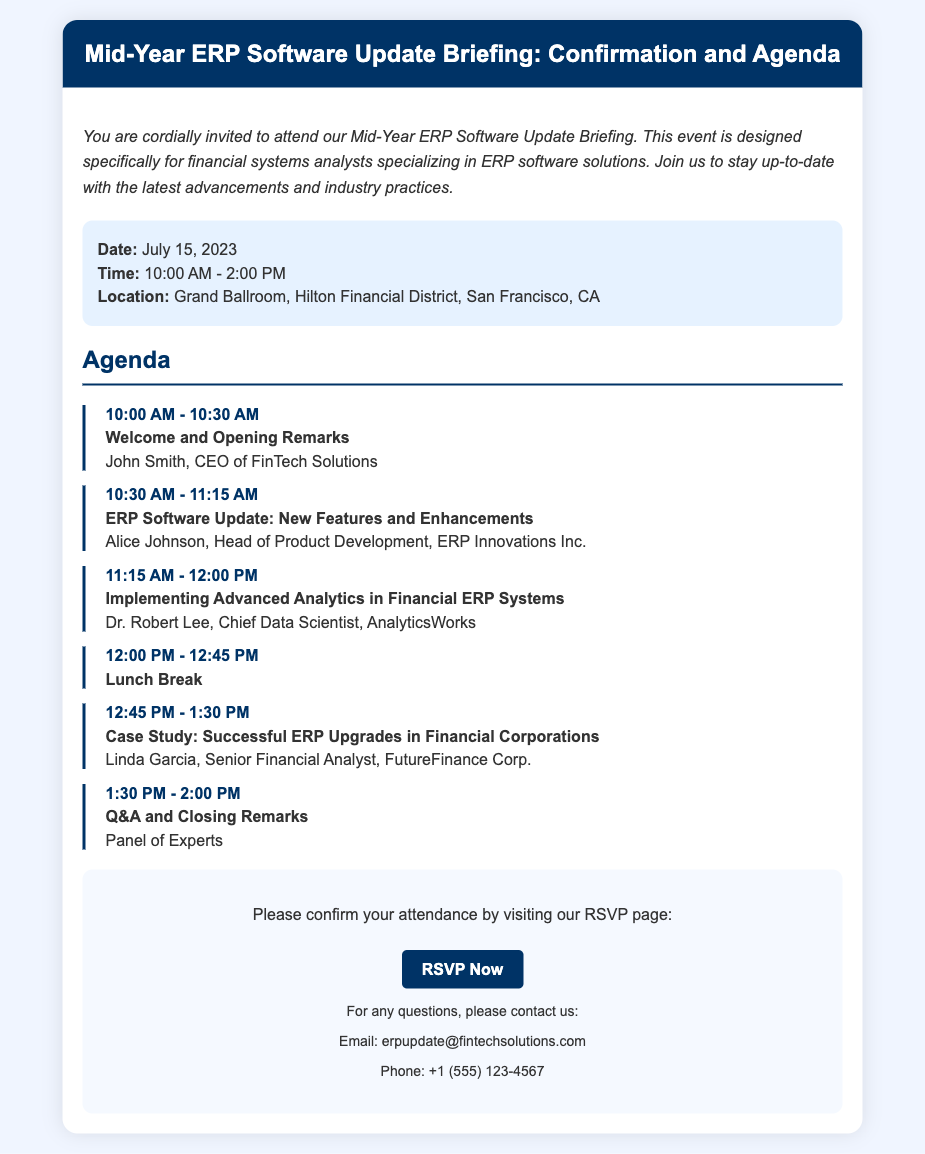What is the date of the briefing? The date is explicitly stated in the event details section of the document.
Answer: July 15, 2023 What time does the briefing start? The start time is listed in the event details of the document.
Answer: 10:00 AM Who is giving the opening remarks? The document specifies the speaker for the opening remarks in the agenda section.
Answer: John Smith What is one of the topics covered at the briefing? The agenda outlines several topics that will be discussed, providing specific examples.
Answer: ERP Software Update: New Features and Enhancements How long is the lunch break? The duration of the lunch break is described in the agenda.
Answer: 45 minutes What is the location of the event? The location is mentioned within the event details of the document.
Answer: Grand Ballroom, Hilton Financial District, San Francisco, CA What is the main purpose of the briefing? The introduction section of the document describes the aim of the event.
Answer: Stay up-to-date with the latest advancements and industry practices What should attendees do to confirm their attendance? The RSVP section instructs attendees on how to confirm attendance.
Answer: Visit our RSVP page What should attendees do if they have questions? The contact information section provides a clear response to this inquiry.
Answer: Contact us via email or phone 